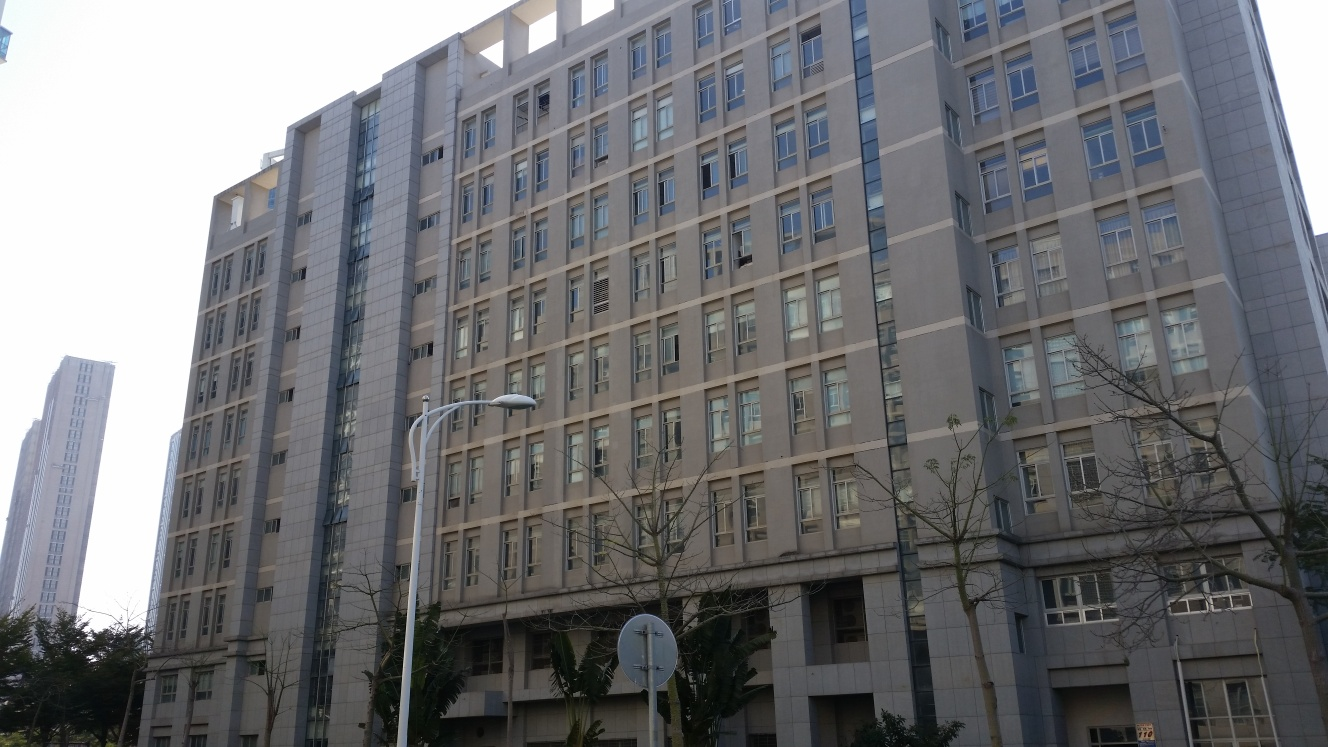What architectural styles does this building represent, and how does it blend with its urban environment? The building represents contemporary urban architectural style characterized by uniform, geometric window patterns and a neutral color palette. This style often aims for functionality and fits well within a dense cityscape by not overpowering surrounding structures but complementing the modern city's aesthetic. Its symmetrical design and subdued tones help it blend seamlessly with both the commercial and residential buildings around it. 